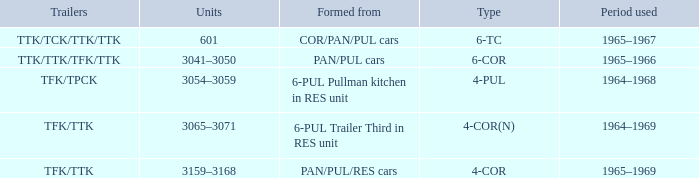Name the typed for formed from 6-pul trailer third in res unit 4-COR(N). 